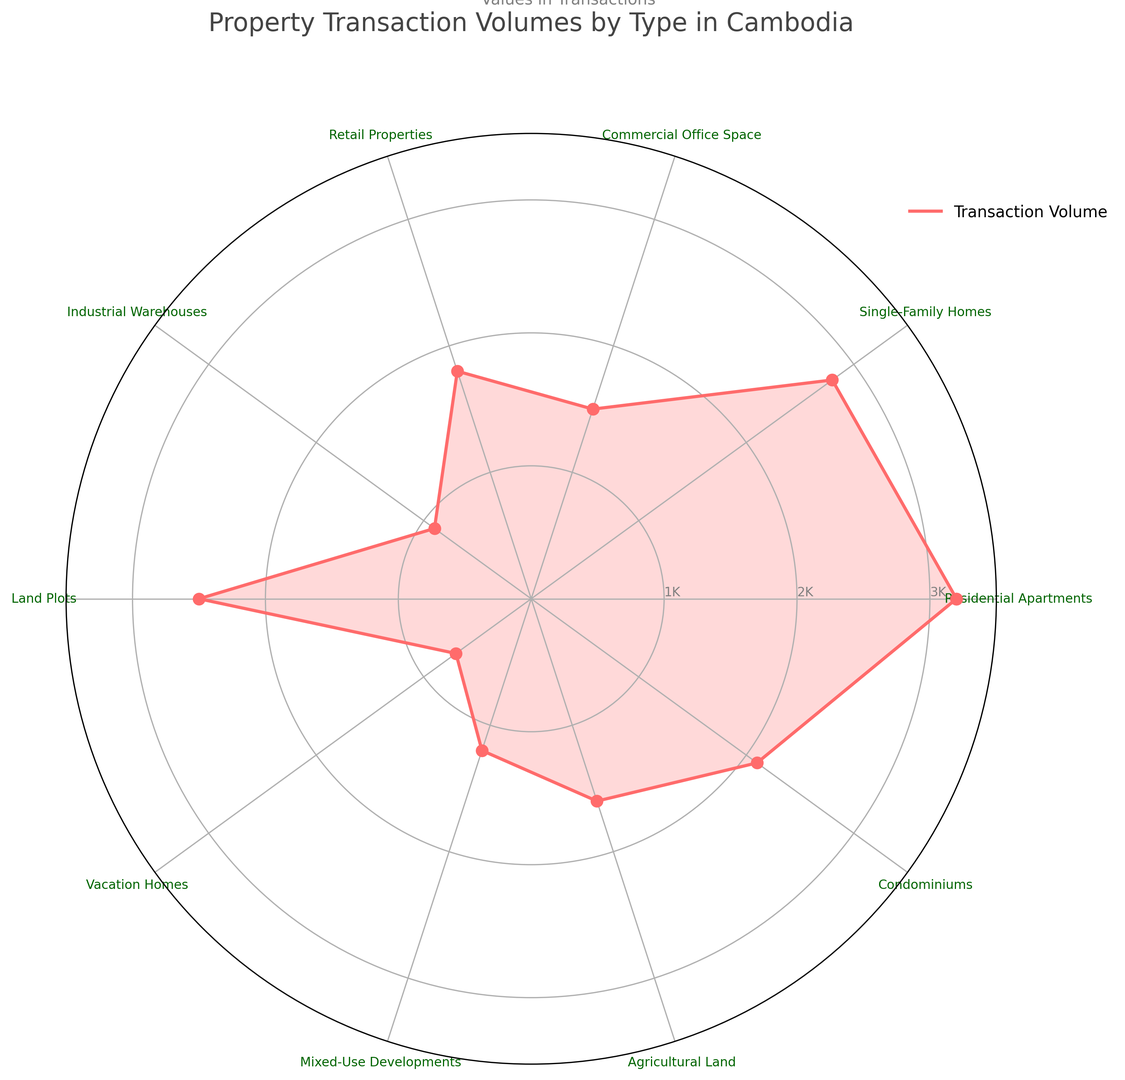How many property types have transaction volumes exceeding 2000? First, identify the categories whose transaction volume exceeds 2000: Residential Apartments (3200), Single-Family Homes (2800), and Condominiums (2100). Thus, there are 3 property types with volumes over 2000.
Answer: 3 Which property type has the highest transaction volume? By examining the radial lines in the radar chart, the Residential Apartments category has the highest peak at 3200.
Answer: Residential Apartments What is the combined transaction volume of Commercial Office Space and Retail Properties? Add the transaction volumes of Commercial Office Space (1500) and Retail Properties (1800): 1500 + 1800 = 3300.
Answer: 3300 How does the volume for Single-Family Homes compare with that for Agricultural Land? The transaction volume for Single-Family Homes is 2800, which is greater than the volume for Agricultural Land at 1600.
Answer: Single-Family Homes Which property type has the smallest transaction volume? From the radar chart, the smallest peak corresponds to Vacation Homes, with a volume of 700.
Answer: Vacation Homes Is the transaction volume for Industrial Warehouses more than that for Mixed-Use Developments? Compare the values: Industrial Warehouses (900) and Mixed-Use Developments (1200). Industrial Warehouses have a lower volume than Mixed-Use Developments.
Answer: No What is the average transaction volume across all property types? Sum the transaction volumes and divide by the number of property types: (3200 + 2800 + 1500 + 1800 + 900 + 2500 + 700 + 1200 + 1600 + 2100) / 10 = 18300 / 10 = 1830.
Answer: 1830 How does the transaction volume for Land Plots and Industrial Warehouses compare to the volume for Residential Apartments? Combine the volumes of Land Plots (2500) and Industrial Warehouses (900): 2500 + 900 = 3400. This is more than the volume for Residential Apartments which is 3200.
Answer: More Which property types fall within the 1000-2000 transaction volume range? Identify the categories in this range: Commercial Office Space (1500), Retail Properties (1800), Mixed-Use Developments (1200), Agricultural Land (1600), and Condominiums (2100, but only the lower bound is 2000). Thus, valid ones are Commercial Office Space, Retail Properties, Mixed-Use Developments, Agricultural Land.
Answer: Commercial Office Space, Retail Properties, Mixed-Use Developments, Agricultural Land What is the difference in transaction volume between the highest and lowest property types? Identify the highest (Residential Apartments at 3200) and the lowest (Vacation Homes at 700) volumes. The difference is 3200 - 700 = 2500.
Answer: 2500 